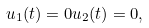Convert formula to latex. <formula><loc_0><loc_0><loc_500><loc_500>u _ { 1 } ( t ) = 0 u _ { 2 } ( t ) = 0 ,</formula> 